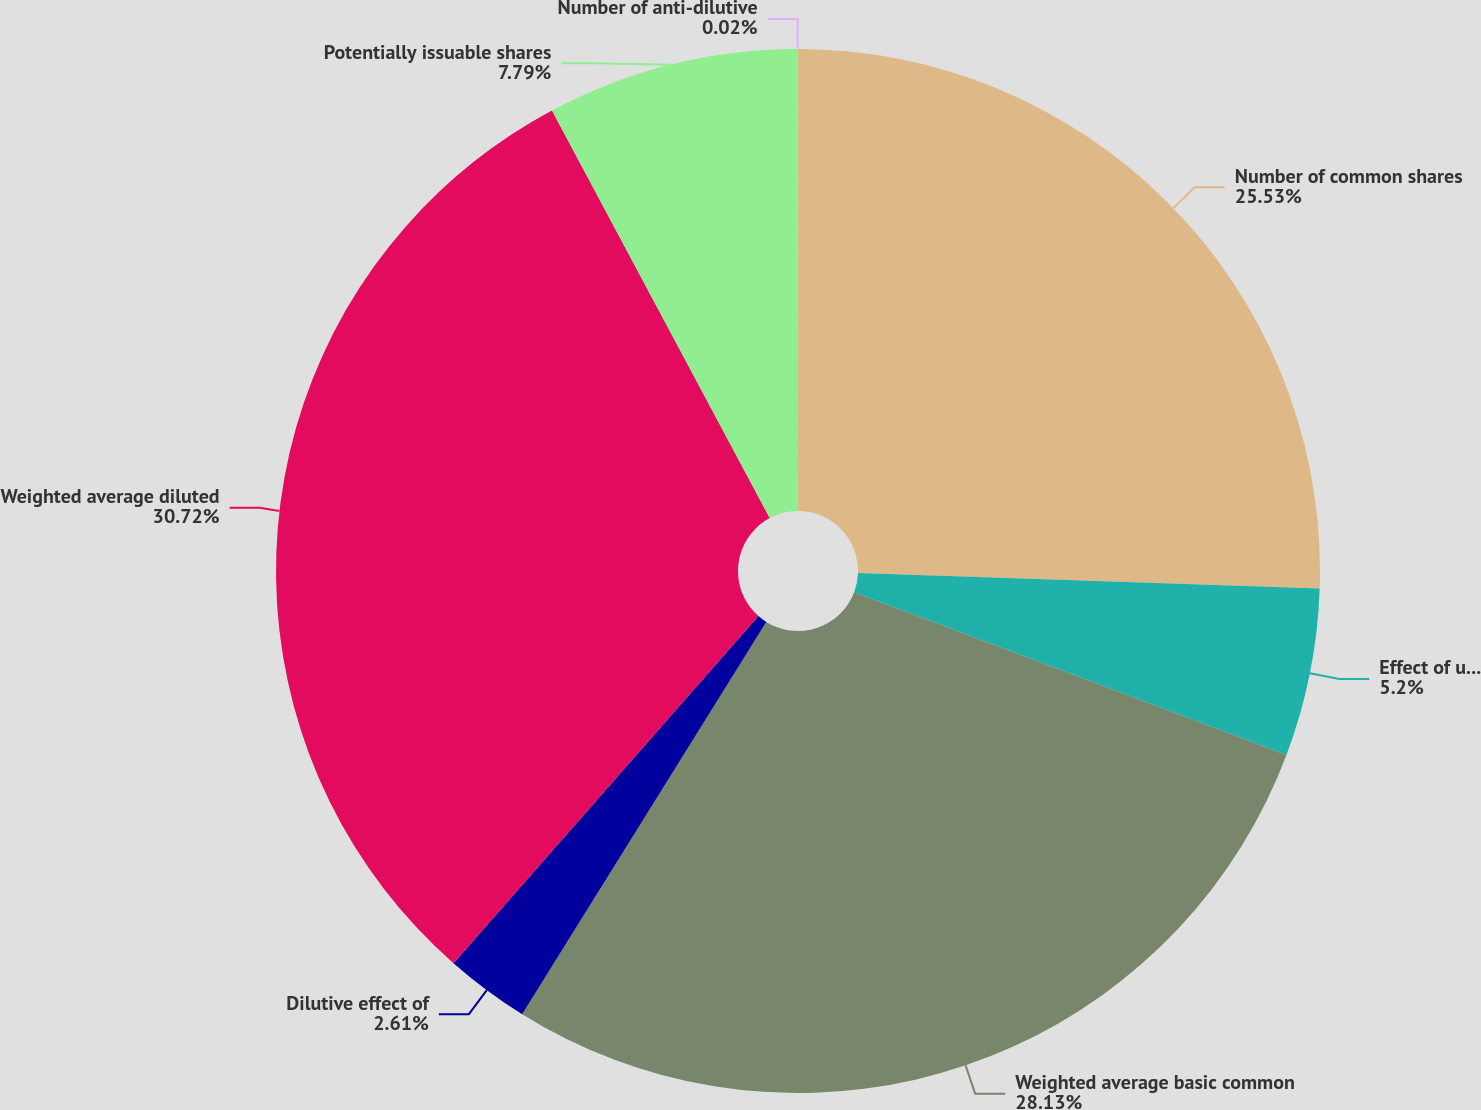Convert chart to OTSL. <chart><loc_0><loc_0><loc_500><loc_500><pie_chart><fcel>Number of common shares<fcel>Effect of using weighted<fcel>Weighted average basic common<fcel>Dilutive effect of<fcel>Weighted average diluted<fcel>Potentially issuable shares<fcel>Number of anti-dilutive<nl><fcel>25.53%<fcel>5.2%<fcel>28.12%<fcel>2.61%<fcel>30.71%<fcel>7.79%<fcel>0.02%<nl></chart> 